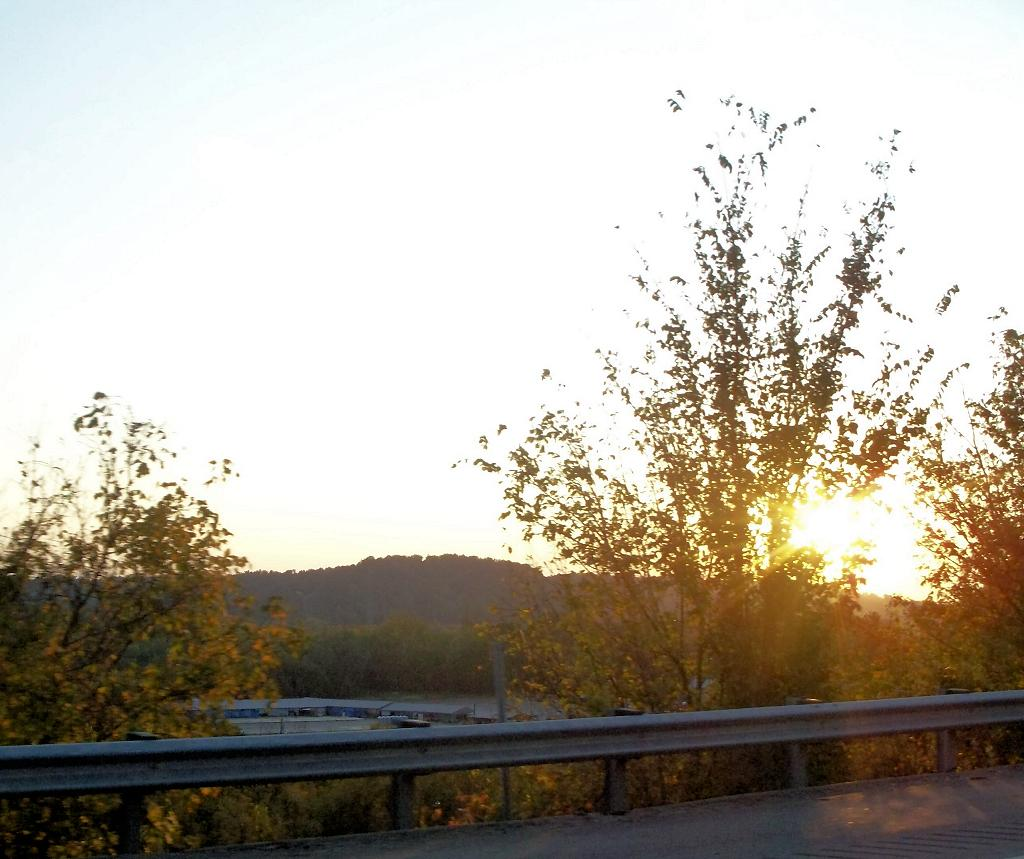What type of natural elements can be seen in the image? There are trees in the image. What geographical feature is present in the image? There is a hill in the image. Are there any man-made structures visible in the image? Yes, there appear to be buildings in the image. What is the source of light in the sky in the image? Sunlight is visible in the sky. What type of barrier can be seen in the image? There is a metal fence in the image. Can you tell me how many shelves are visible in the image? There are no shelves present in the image. What direction do the buildings in the image turn? The buildings in the image do not turn; they are stationary structures. 